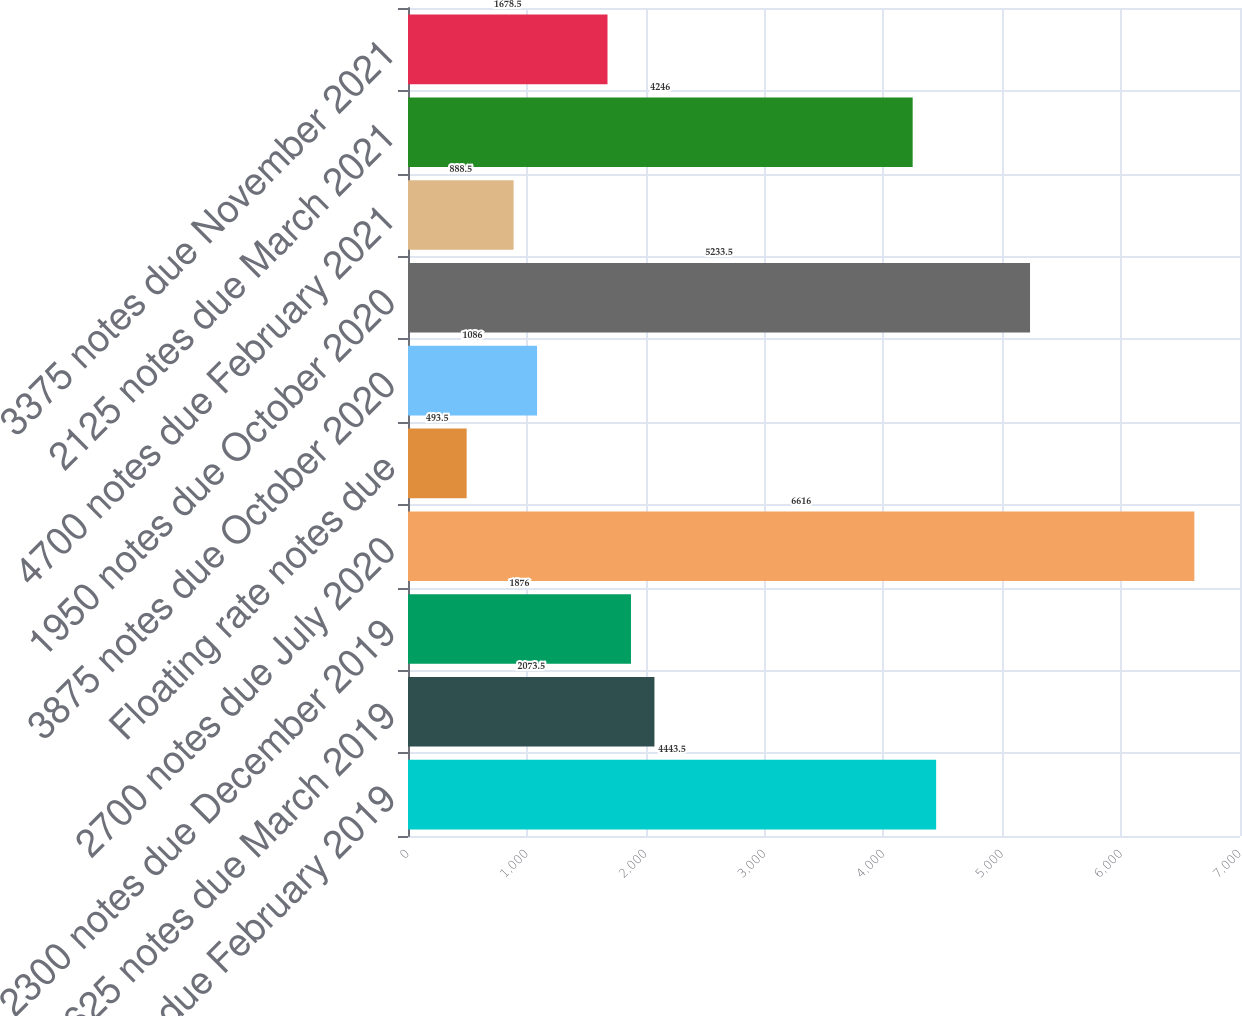Convert chart. <chart><loc_0><loc_0><loc_500><loc_500><bar_chart><fcel>1700 notes due February 2019<fcel>1625 notes due March 2019<fcel>2300 notes due December 2019<fcel>2700 notes due July 2020<fcel>Floating rate notes due<fcel>3875 notes due October 2020<fcel>1950 notes due October 2020<fcel>4700 notes due February 2021<fcel>2125 notes due March 2021<fcel>3375 notes due November 2021<nl><fcel>4443.5<fcel>2073.5<fcel>1876<fcel>6616<fcel>493.5<fcel>1086<fcel>5233.5<fcel>888.5<fcel>4246<fcel>1678.5<nl></chart> 